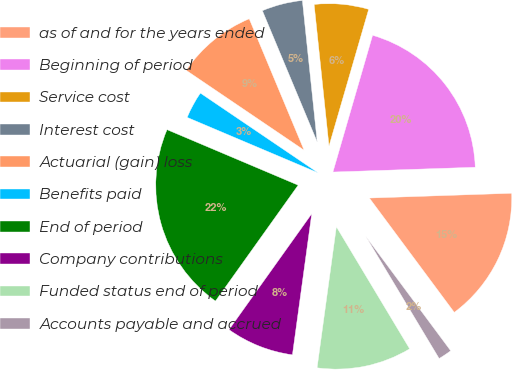Convert chart. <chart><loc_0><loc_0><loc_500><loc_500><pie_chart><fcel>as of and for the years ended<fcel>Beginning of period<fcel>Service cost<fcel>Interest cost<fcel>Actuarial (gain) loss<fcel>Benefits paid<fcel>End of period<fcel>Company contributions<fcel>Funded status end of period<fcel>Accounts payable and accrued<nl><fcel>15.37%<fcel>19.97%<fcel>6.16%<fcel>4.63%<fcel>9.23%<fcel>3.1%<fcel>21.51%<fcel>7.7%<fcel>10.77%<fcel>1.56%<nl></chart> 